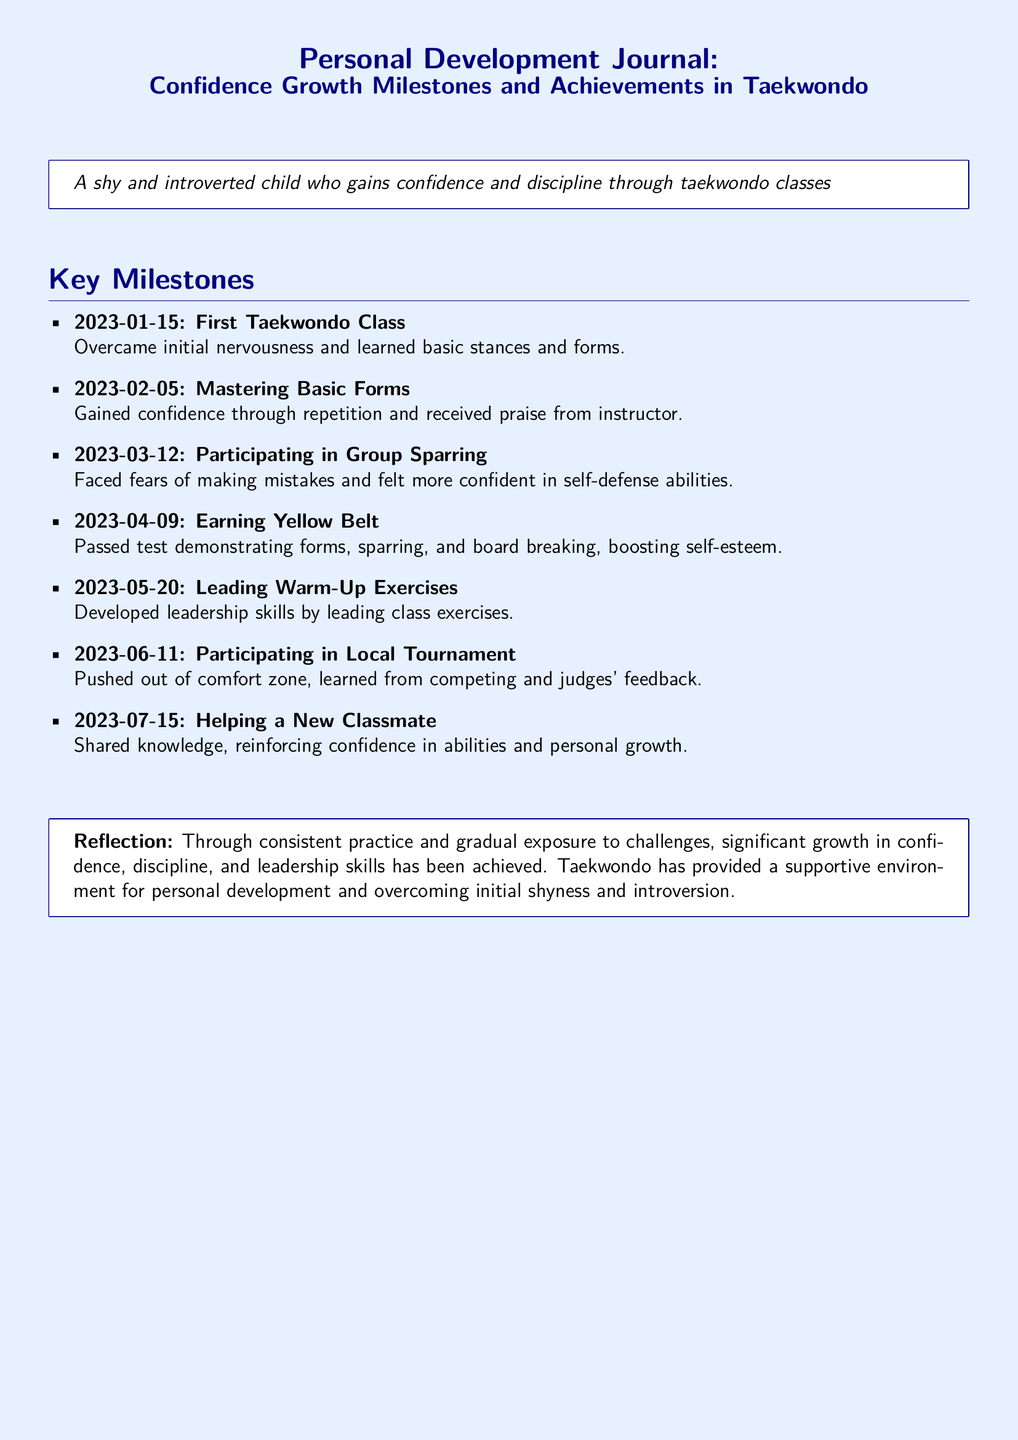What date did the first taekwondo class occur? The first taekwondo class date is explicitly mentioned in the document as January 15, 2023.
Answer: January 15, 2023 What milestone was achieved on April 9, 2023? The document states that on this date, the individual earned their yellow belt, indicating a significant achievement.
Answer: Earning Yellow Belt How did the child feel after participating in group sparring? The document indicates that participating in group sparring helped the child face fears and feel more confident in self-defense abilities.
Answer: More confident What did the child do on May 20, 2023? The document explicitly states that the child led warm-up exercises, demonstrating leadership skills.
Answer: Leading Warm-Up Exercises How many months passed between the first class and earning the yellow belt? The milestones are listed, and the first class is on January 15 and the yellow belt was earned on April 9, 2023. Counting the months gives us approximately three months.
Answer: 3 months What does the reflection mention about the learning environment? The reflection highlights that taekwondo provided a supportive environment for personal development.
Answer: Supportive environment What activity was performed on June 11, 2023? The document specifies that the child participated in a local tournament on this date.
Answer: Participating in Local Tournament What skills were developed according to the reflection? The reflection notes significant growth in confidence, discipline, and leadership skills achieved through taekwondo.
Answer: Confidence, discipline, leadership skills 